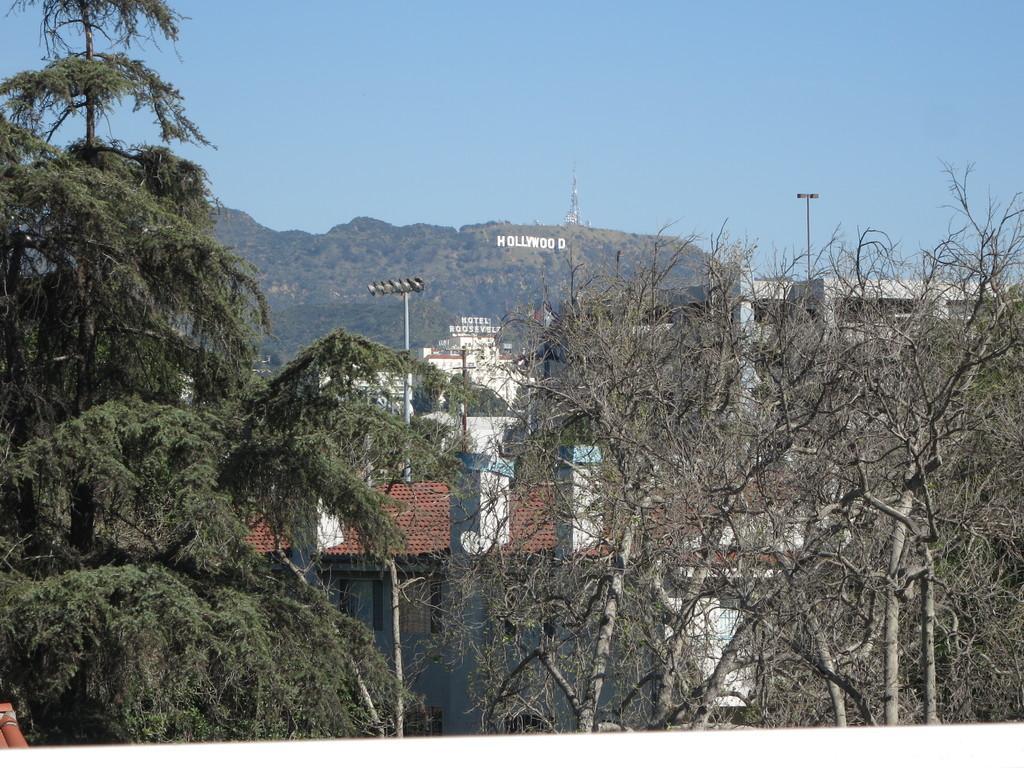Describe this image in one or two sentences. In this image I see number of trees and I see number of buildings and I see 2 poles and I see something is written over here and I see the clear sky. 